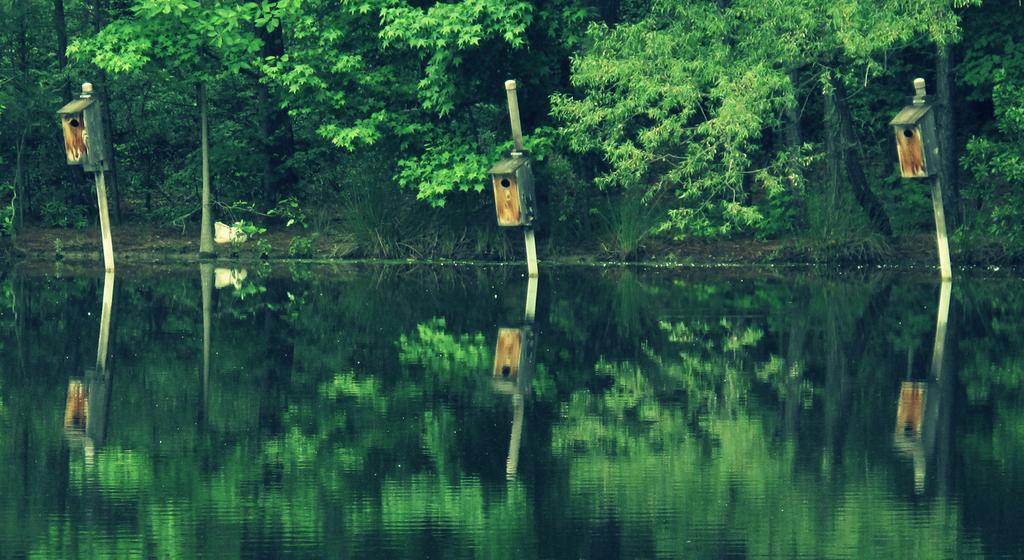What is located at the bottom of the image? There is a river at the bottom of the image. What can be seen in the background of the image? There are trees, poles, and boxes in the background of the image. What type of sink can be seen in the image? There is no sink present in the image. What record is being played in the background of the image? There is no record or music being played in the image. 